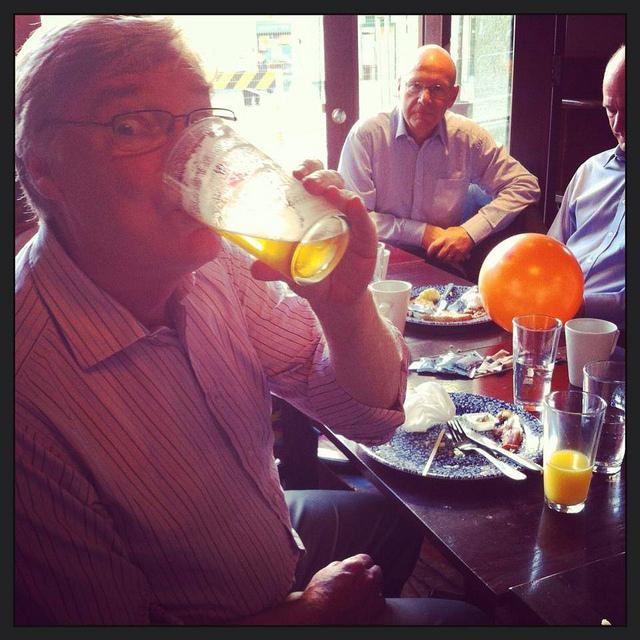What drug is this man ingesting?

Choices:
A) marijuana
B) cocaine
C) mdma
D) alcohol alcohol 